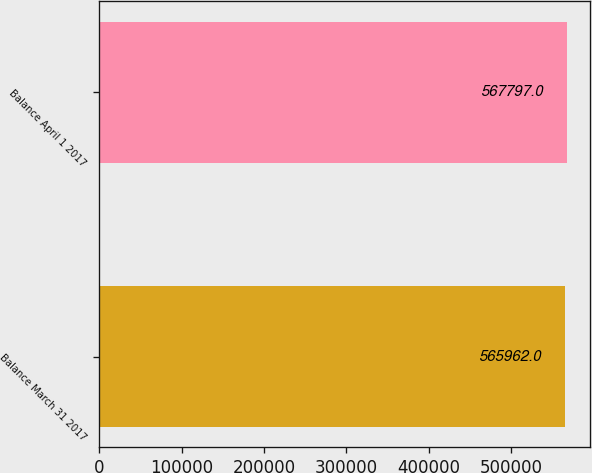Convert chart to OTSL. <chart><loc_0><loc_0><loc_500><loc_500><bar_chart><fcel>Balance March 31 2017<fcel>Balance April 1 2017<nl><fcel>565962<fcel>567797<nl></chart> 